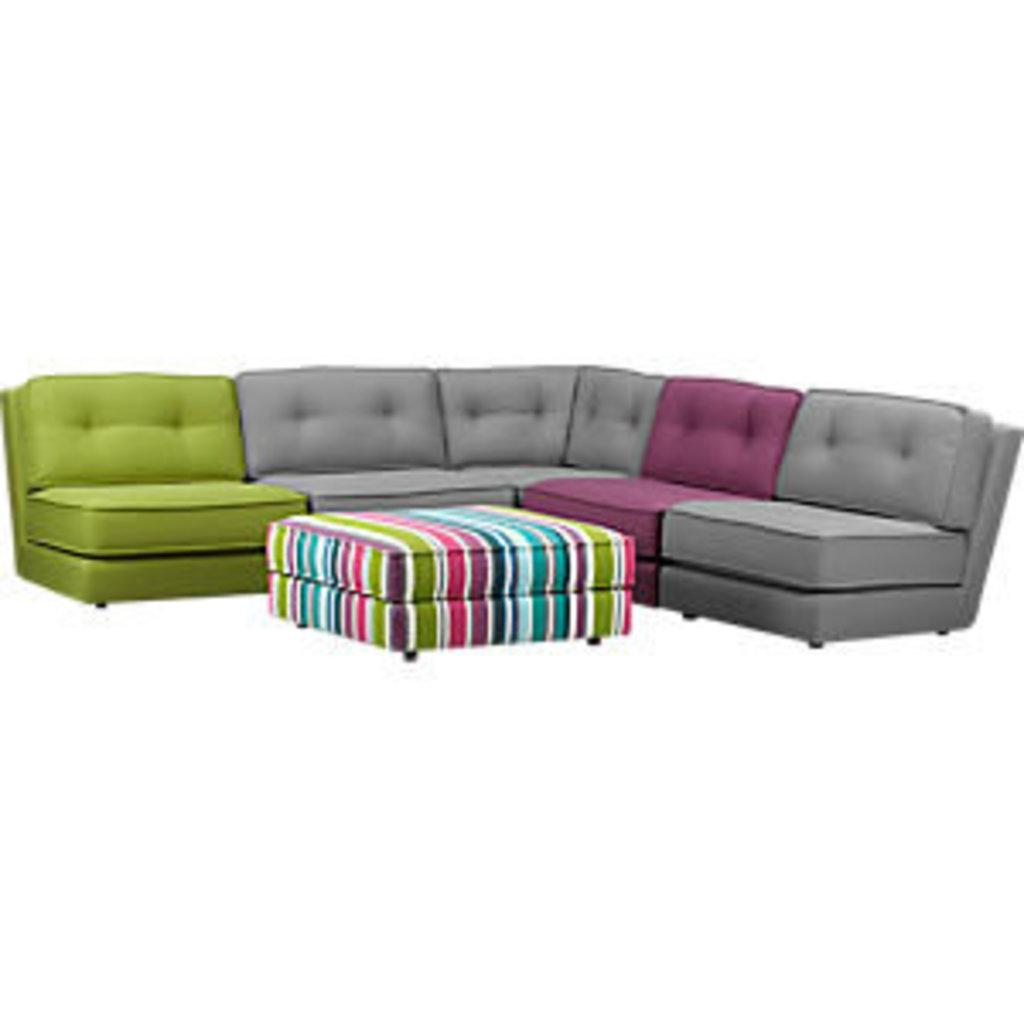What type of furniture is visible in the image? There is a sofa set in the image. What is placed in front of the sofa set? There is a table placed in front of the sofa set. What color is the background of the image? The background of the image appears to be white. Can you see a plough in the image? No, there is no plough present in the image. 